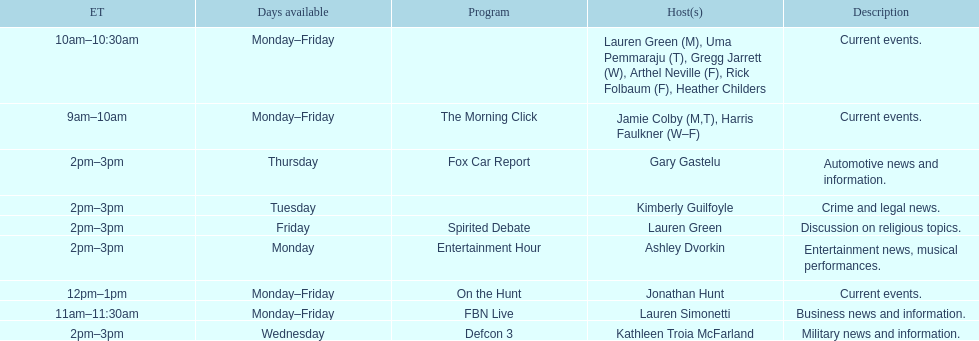Give me the full table as a dictionary. {'header': ['ET', 'Days available', 'Program', 'Host(s)', 'Description'], 'rows': [['10am–10:30am', 'Monday–Friday', '', 'Lauren Green (M), Uma Pemmaraju (T), Gregg Jarrett (W), Arthel Neville (F), Rick Folbaum (F), Heather Childers', 'Current events.'], ['9am–10am', 'Monday–Friday', 'The Morning Click', 'Jamie Colby (M,T), Harris Faulkner (W–F)', 'Current events.'], ['2pm–3pm', 'Thursday', 'Fox Car Report', 'Gary Gastelu', 'Automotive news and information.'], ['2pm–3pm', 'Tuesday', '', 'Kimberly Guilfoyle', 'Crime and legal news.'], ['2pm–3pm', 'Friday', 'Spirited Debate', 'Lauren Green', 'Discussion on religious topics.'], ['2pm–3pm', 'Monday', 'Entertainment Hour', 'Ashley Dvorkin', 'Entertainment news, musical performances.'], ['12pm–1pm', 'Monday–Friday', 'On the Hunt', 'Jonathan Hunt', 'Current events.'], ['11am–11:30am', 'Monday–Friday', 'FBN Live', 'Lauren Simonetti', 'Business news and information.'], ['2pm–3pm', 'Wednesday', 'Defcon 3', 'Kathleen Troia McFarland', 'Military news and information.']]} How many days during the week does the show fbn live air? 5. 